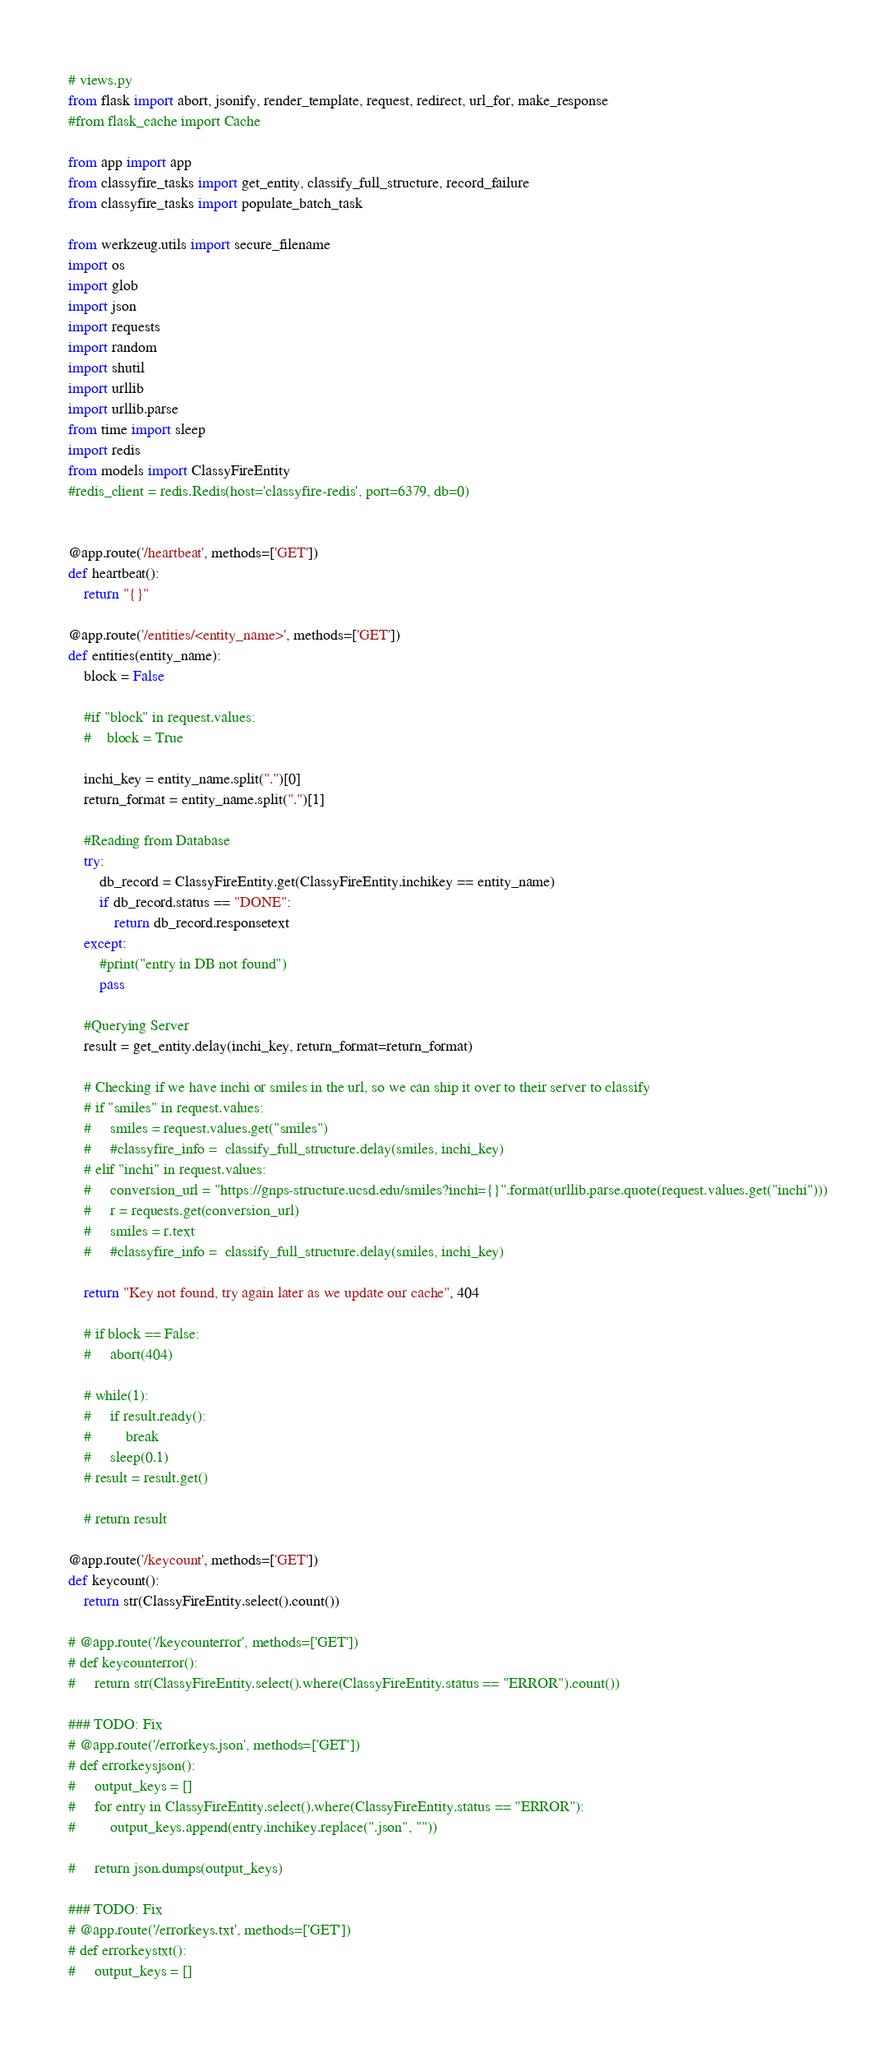Convert code to text. <code><loc_0><loc_0><loc_500><loc_500><_Python_># views.py
from flask import abort, jsonify, render_template, request, redirect, url_for, make_response
#from flask_cache import Cache

from app import app
from classyfire_tasks import get_entity, classify_full_structure, record_failure
from classyfire_tasks import populate_batch_task

from werkzeug.utils import secure_filename
import os
import glob
import json
import requests
import random
import shutil
import urllib
import urllib.parse
from time import sleep
import redis
from models import ClassyFireEntity
#redis_client = redis.Redis(host='classyfire-redis', port=6379, db=0)


@app.route('/heartbeat', methods=['GET'])
def heartbeat():
    return "{}"

@app.route('/entities/<entity_name>', methods=['GET'])
def entities(entity_name):
    block = False

    #if "block" in request.values:
    #    block = True

    inchi_key = entity_name.split(".")[0]
    return_format = entity_name.split(".")[1]

    #Reading from Database
    try:
        db_record = ClassyFireEntity.get(ClassyFireEntity.inchikey == entity_name)
        if db_record.status == "DONE":
            return db_record.responsetext
    except:
        #print("entry in DB not found")
        pass
    
    #Querying Server
    result = get_entity.delay(inchi_key, return_format=return_format)

    # Checking if we have inchi or smiles in the url, so we can ship it over to their server to classify
    # if "smiles" in request.values:
    #     smiles = request.values.get("smiles")
    #     #classyfire_info =  classify_full_structure.delay(smiles, inchi_key)
    # elif "inchi" in request.values:
    #     conversion_url = "https://gnps-structure.ucsd.edu/smiles?inchi={}".format(urllib.parse.quote(request.values.get("inchi")))
    #     r = requests.get(conversion_url)
    #     smiles = r.text
    #     #classyfire_info =  classify_full_structure.delay(smiles, inchi_key)

    return "Key not found, try again later as we update our cache", 404

    # if block == False:
    #     abort(404)

    # while(1):
    #     if result.ready():
    #         break
    #     sleep(0.1)
    # result = result.get()
    
    # return result

@app.route('/keycount', methods=['GET'])
def keycount():
    return str(ClassyFireEntity.select().count())

# @app.route('/keycounterror', methods=['GET'])
# def keycounterror():
#     return str(ClassyFireEntity.select().where(ClassyFireEntity.status == "ERROR").count())

### TODO: Fix
# @app.route('/errorkeys.json', methods=['GET'])
# def errorkeysjson():
#     output_keys = []
#     for entry in ClassyFireEntity.select().where(ClassyFireEntity.status == "ERROR"):
#         output_keys.append(entry.inchikey.replace(".json", ""))

#     return json.dumps(output_keys)

### TODO: Fix
# @app.route('/errorkeys.txt', methods=['GET'])
# def errorkeystxt():
#     output_keys = []</code> 